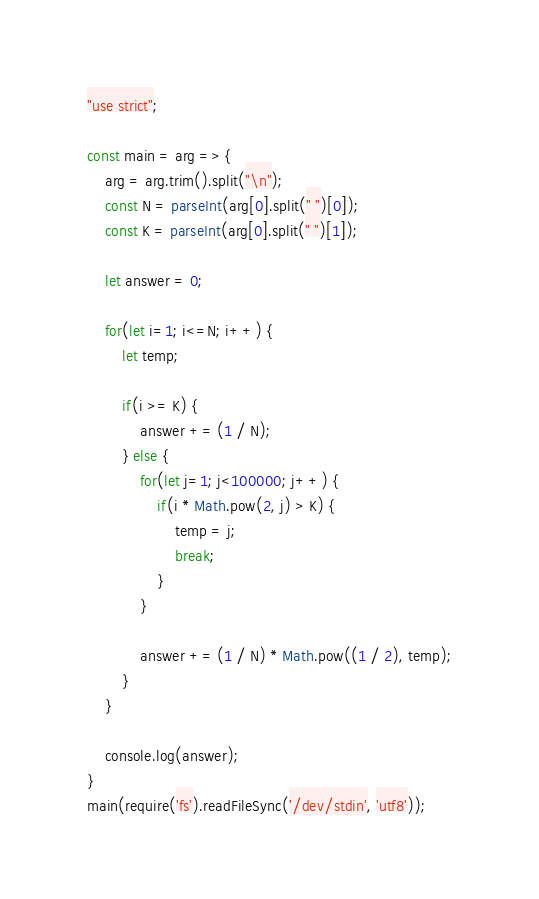Convert code to text. <code><loc_0><loc_0><loc_500><loc_500><_JavaScript_>"use strict";
    
const main = arg => {
    arg = arg.trim().split("\n");
    const N = parseInt(arg[0].split(" ")[0]);
    const K = parseInt(arg[0].split(" ")[1]);
    
    let answer = 0;
    
    for(let i=1; i<=N; i++) {
        let temp;
        
        if(i >= K) {
            answer += (1 / N);
        } else {
            for(let j=1; j<100000; j++) {
                if(i * Math.pow(2, j) > K) {
                    temp = j;
                    break;
                }
            }
    
            answer += (1 / N) * Math.pow((1 / 2), temp);
        }
    }
    
    console.log(answer);
}
main(require('fs').readFileSync('/dev/stdin', 'utf8'));
</code> 